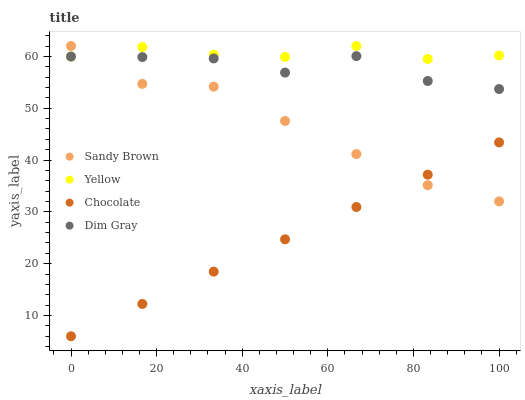Does Chocolate have the minimum area under the curve?
Answer yes or no. Yes. Does Yellow have the maximum area under the curve?
Answer yes or no. Yes. Does Sandy Brown have the minimum area under the curve?
Answer yes or no. No. Does Sandy Brown have the maximum area under the curve?
Answer yes or no. No. Is Chocolate the smoothest?
Answer yes or no. Yes. Is Dim Gray the roughest?
Answer yes or no. Yes. Is Sandy Brown the smoothest?
Answer yes or no. No. Is Sandy Brown the roughest?
Answer yes or no. No. Does Chocolate have the lowest value?
Answer yes or no. Yes. Does Sandy Brown have the lowest value?
Answer yes or no. No. Does Yellow have the highest value?
Answer yes or no. Yes. Does Chocolate have the highest value?
Answer yes or no. No. Is Chocolate less than Yellow?
Answer yes or no. Yes. Is Yellow greater than Chocolate?
Answer yes or no. Yes. Does Yellow intersect Sandy Brown?
Answer yes or no. Yes. Is Yellow less than Sandy Brown?
Answer yes or no. No. Is Yellow greater than Sandy Brown?
Answer yes or no. No. Does Chocolate intersect Yellow?
Answer yes or no. No. 